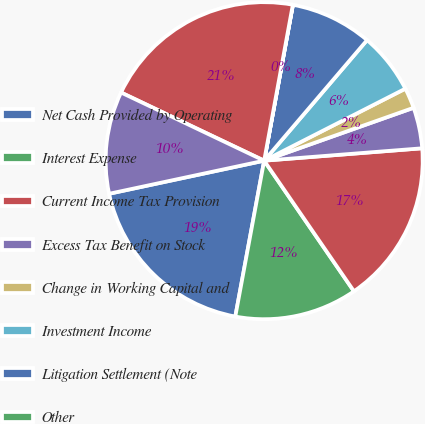Convert chart to OTSL. <chart><loc_0><loc_0><loc_500><loc_500><pie_chart><fcel>Net Cash Provided by Operating<fcel>Interest Expense<fcel>Current Income Tax Provision<fcel>Excess Tax Benefit on Stock<fcel>Change in Working Capital and<fcel>Investment Income<fcel>Litigation Settlement (Note<fcel>Other<fcel>Adjusted EBITDA (per loan<fcel>Net Cash Used in Investing<nl><fcel>18.74%<fcel>12.5%<fcel>16.66%<fcel>4.17%<fcel>2.09%<fcel>6.25%<fcel>8.34%<fcel>0.01%<fcel>20.82%<fcel>10.42%<nl></chart> 